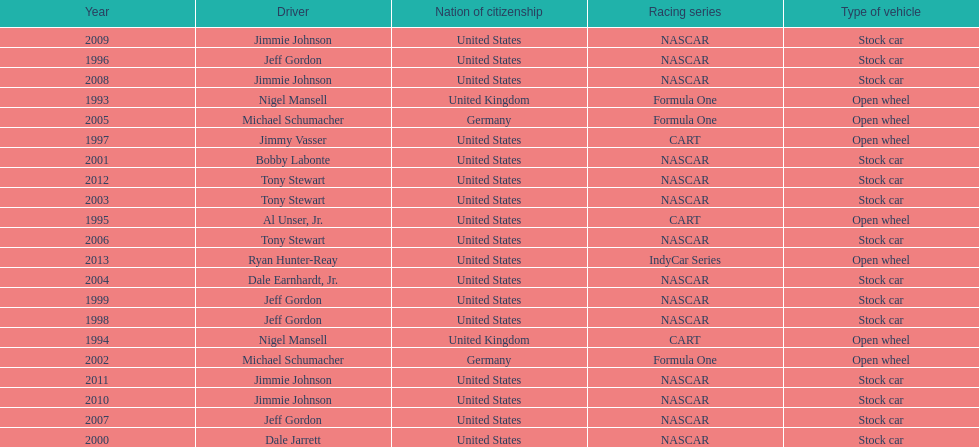Give me the full table as a dictionary. {'header': ['Year', 'Driver', 'Nation of citizenship', 'Racing series', 'Type of vehicle'], 'rows': [['2009', 'Jimmie Johnson', 'United States', 'NASCAR', 'Stock car'], ['1996', 'Jeff Gordon', 'United States', 'NASCAR', 'Stock car'], ['2008', 'Jimmie Johnson', 'United States', 'NASCAR', 'Stock car'], ['1993', 'Nigel Mansell', 'United Kingdom', 'Formula One', 'Open wheel'], ['2005', 'Michael Schumacher', 'Germany', 'Formula One', 'Open wheel'], ['1997', 'Jimmy Vasser', 'United States', 'CART', 'Open wheel'], ['2001', 'Bobby Labonte', 'United States', 'NASCAR', 'Stock car'], ['2012', 'Tony Stewart', 'United States', 'NASCAR', 'Stock car'], ['2003', 'Tony Stewart', 'United States', 'NASCAR', 'Stock car'], ['1995', 'Al Unser, Jr.', 'United States', 'CART', 'Open wheel'], ['2006', 'Tony Stewart', 'United States', 'NASCAR', 'Stock car'], ['2013', 'Ryan Hunter-Reay', 'United States', 'IndyCar Series', 'Open wheel'], ['2004', 'Dale Earnhardt, Jr.', 'United States', 'NASCAR', 'Stock car'], ['1999', 'Jeff Gordon', 'United States', 'NASCAR', 'Stock car'], ['1998', 'Jeff Gordon', 'United States', 'NASCAR', 'Stock car'], ['1994', 'Nigel Mansell', 'United Kingdom', 'CART', 'Open wheel'], ['2002', 'Michael Schumacher', 'Germany', 'Formula One', 'Open wheel'], ['2011', 'Jimmie Johnson', 'United States', 'NASCAR', 'Stock car'], ['2010', 'Jimmie Johnson', 'United States', 'NASCAR', 'Stock car'], ['2007', 'Jeff Gordon', 'United States', 'NASCAR', 'Stock car'], ['2000', 'Dale Jarrett', 'United States', 'NASCAR', 'Stock car']]} Jimmy johnson won how many consecutive espy awards? 4. 